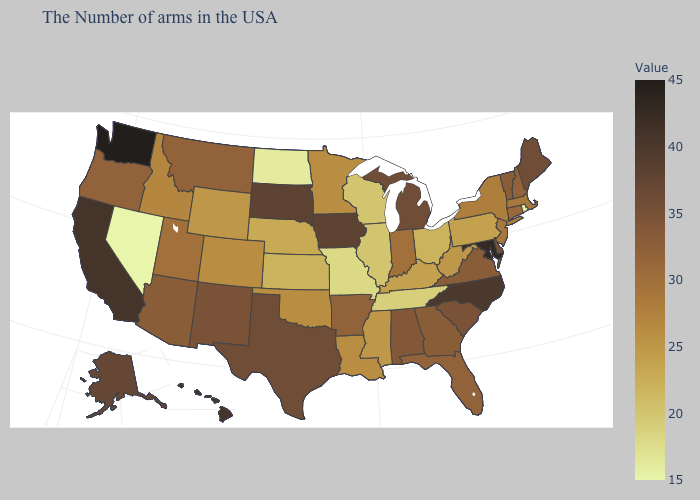Is the legend a continuous bar?
Be succinct. Yes. Does Nevada have the lowest value in the USA?
Write a very short answer. Yes. Among the states that border Utah , does Arizona have the lowest value?
Keep it brief. No. Which states have the lowest value in the South?
Concise answer only. Tennessee. Which states have the lowest value in the South?
Give a very brief answer. Tennessee. Which states have the lowest value in the USA?
Give a very brief answer. Nevada. Does Nevada have the lowest value in the West?
Keep it brief. Yes. Does the map have missing data?
Answer briefly. No. 